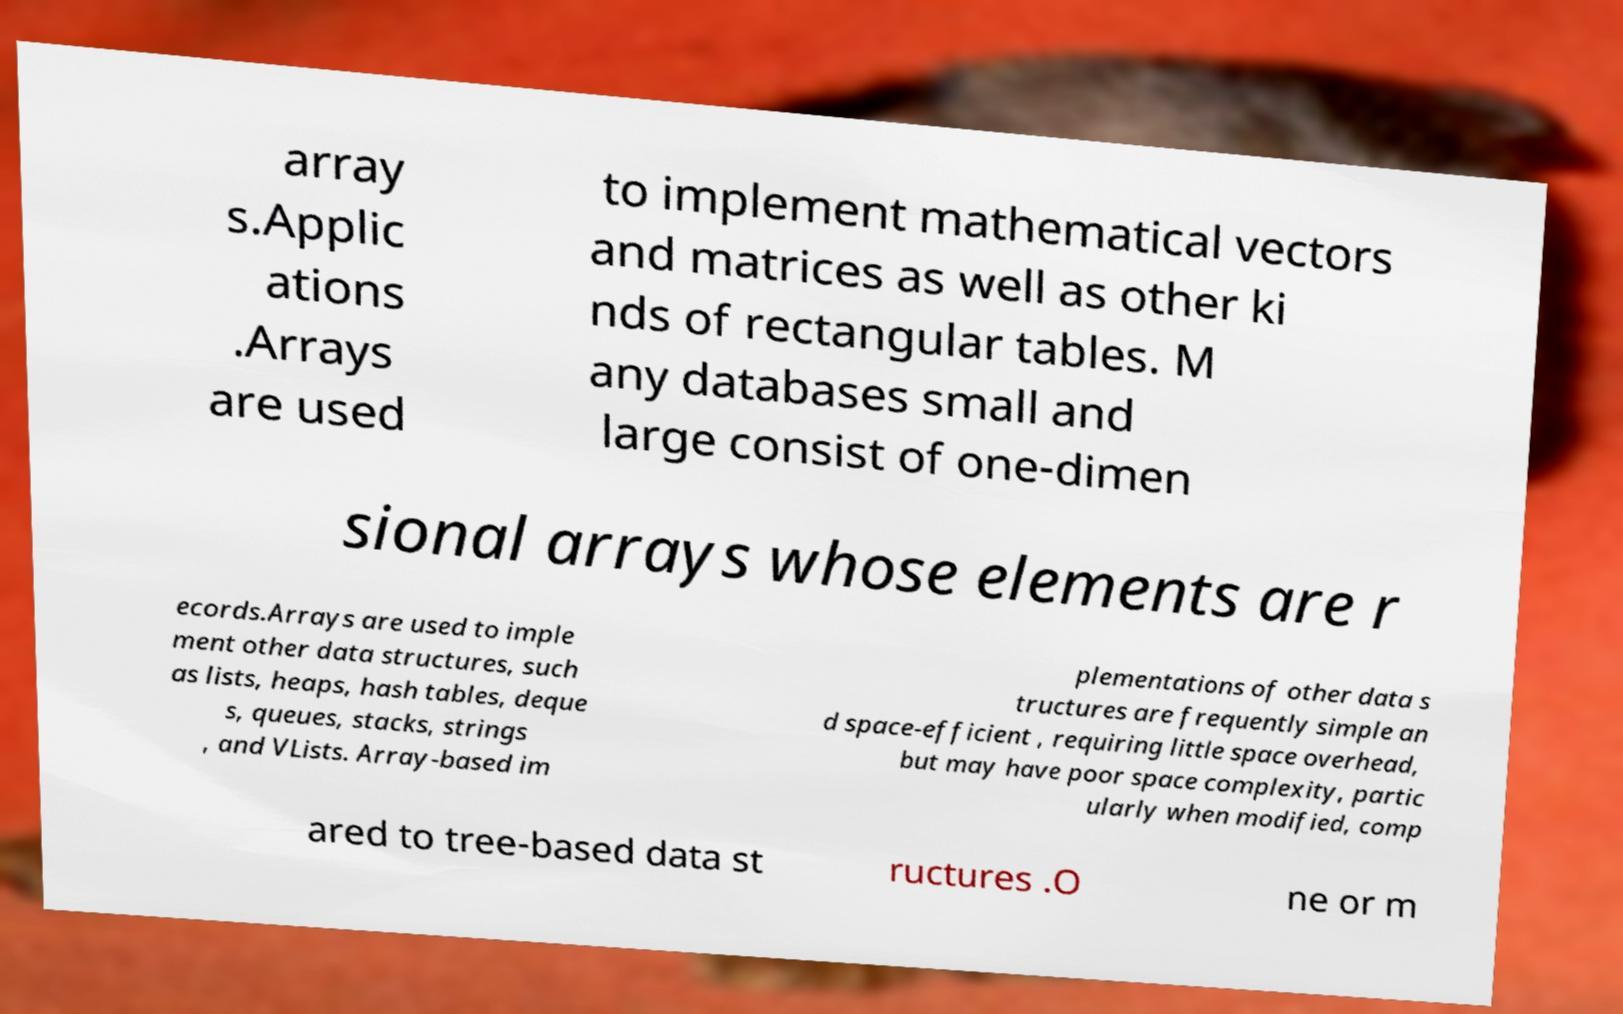Could you extract and type out the text from this image? array s.Applic ations .Arrays are used to implement mathematical vectors and matrices as well as other ki nds of rectangular tables. M any databases small and large consist of one-dimen sional arrays whose elements are r ecords.Arrays are used to imple ment other data structures, such as lists, heaps, hash tables, deque s, queues, stacks, strings , and VLists. Array-based im plementations of other data s tructures are frequently simple an d space-efficient , requiring little space overhead, but may have poor space complexity, partic ularly when modified, comp ared to tree-based data st ructures .O ne or m 